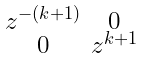<formula> <loc_0><loc_0><loc_500><loc_500>\begin{smallmatrix} z ^ { - ( k + 1 ) } & 0 \\ 0 & z ^ { k + 1 } \end{smallmatrix}</formula> 